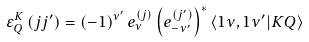<formula> <loc_0><loc_0><loc_500><loc_500>\varepsilon _ { Q } ^ { K } \left ( j j ^ { \prime } \right ) = \left ( - 1 \right ) ^ { \nu ^ { \prime } } e _ { \nu } ^ { \left ( j \right ) } \left ( e _ { - \nu ^ { \prime } } ^ { \left ( j ^ { \prime } \right ) } \right ) ^ { \ast } \left \langle 1 \nu , 1 \nu ^ { \prime } | K Q \right \rangle</formula> 